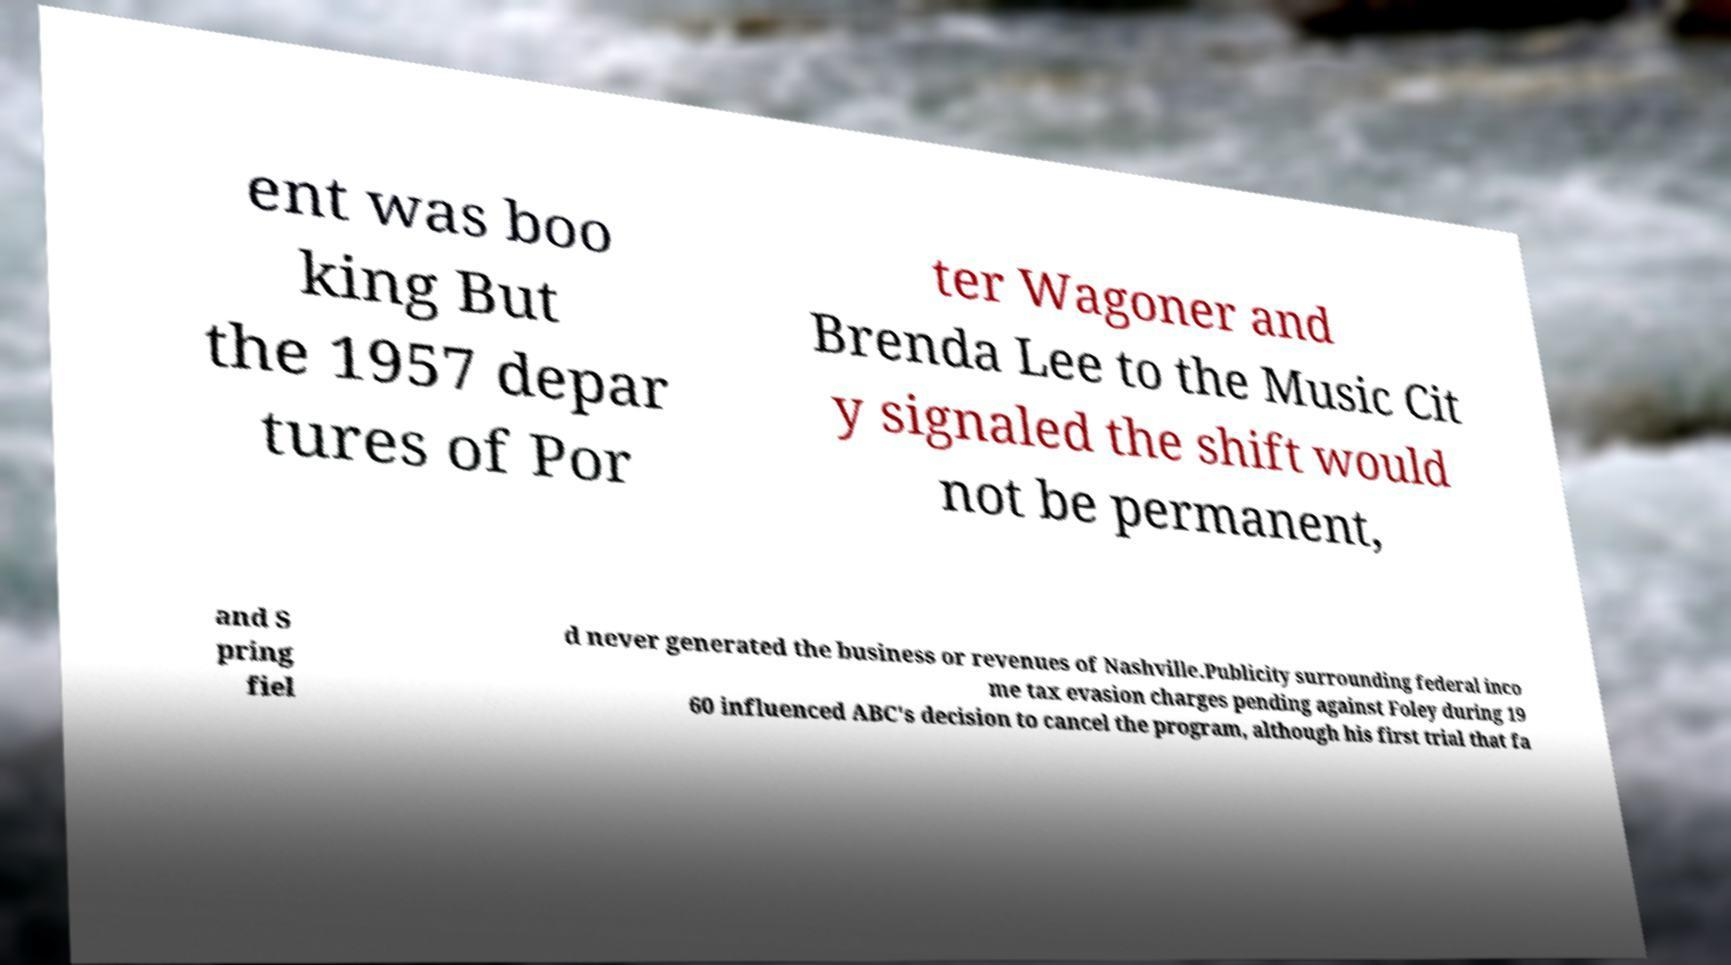Can you accurately transcribe the text from the provided image for me? ent was boo king But the 1957 depar tures of Por ter Wagoner and Brenda Lee to the Music Cit y signaled the shift would not be permanent, and S pring fiel d never generated the business or revenues of Nashville.Publicity surrounding federal inco me tax evasion charges pending against Foley during 19 60 influenced ABC's decision to cancel the program, although his first trial that fa 